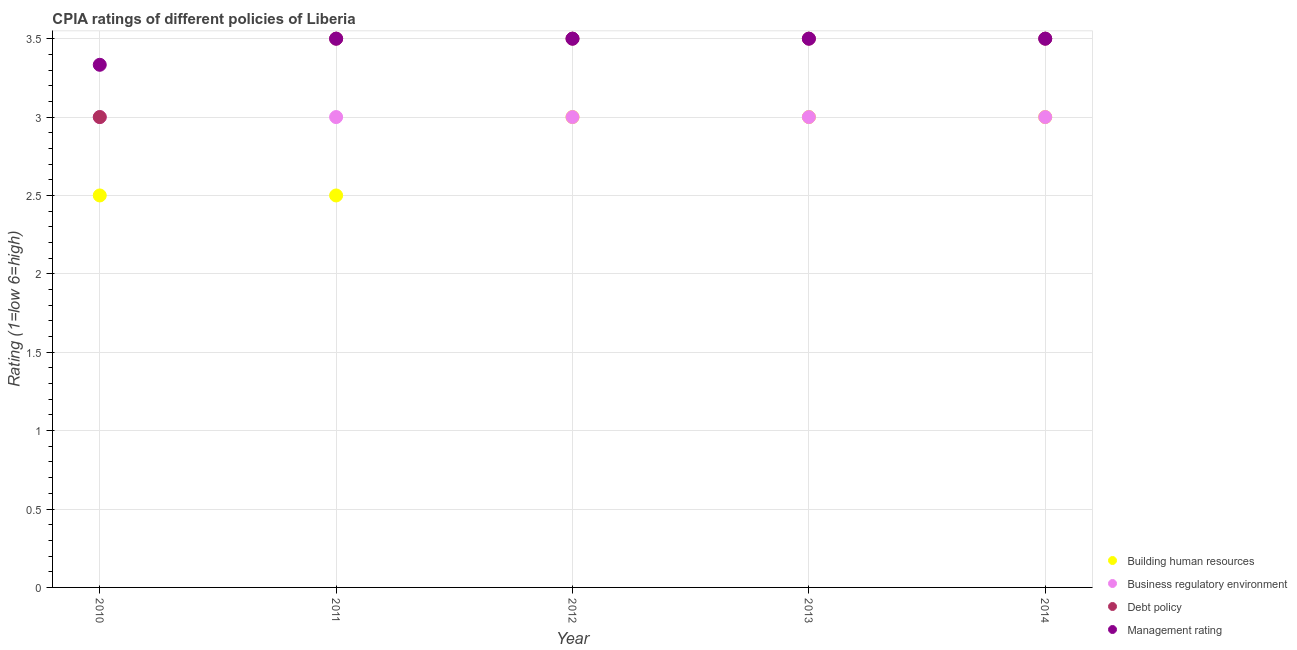Across all years, what is the minimum cpia rating of building human resources?
Offer a very short reply. 2.5. In which year was the cpia rating of management maximum?
Your answer should be compact. 2011. What is the total cpia rating of debt policy in the graph?
Offer a terse response. 17. What is the difference between the cpia rating of debt policy in 2010 and that in 2014?
Give a very brief answer. -0.5. What is the difference between the cpia rating of business regulatory environment in 2011 and the cpia rating of management in 2012?
Keep it short and to the point. -0.5. What is the average cpia rating of management per year?
Make the answer very short. 3.47. In the year 2014, what is the difference between the cpia rating of business regulatory environment and cpia rating of management?
Provide a succinct answer. -0.5. In how many years, is the cpia rating of management greater than 1?
Your response must be concise. 5. What is the ratio of the cpia rating of building human resources in 2012 to that in 2013?
Ensure brevity in your answer.  1. Is the cpia rating of debt policy in 2010 less than that in 2014?
Keep it short and to the point. Yes. Is the difference between the cpia rating of building human resources in 2011 and 2014 greater than the difference between the cpia rating of management in 2011 and 2014?
Make the answer very short. No. In how many years, is the cpia rating of building human resources greater than the average cpia rating of building human resources taken over all years?
Your response must be concise. 3. Is the sum of the cpia rating of business regulatory environment in 2010 and 2012 greater than the maximum cpia rating of management across all years?
Keep it short and to the point. Yes. Does the cpia rating of management monotonically increase over the years?
Provide a short and direct response. No. Is the cpia rating of building human resources strictly greater than the cpia rating of debt policy over the years?
Make the answer very short. No. How many years are there in the graph?
Make the answer very short. 5. Are the values on the major ticks of Y-axis written in scientific E-notation?
Your response must be concise. No. Does the graph contain any zero values?
Provide a succinct answer. No. Does the graph contain grids?
Provide a short and direct response. Yes. Where does the legend appear in the graph?
Your response must be concise. Bottom right. How many legend labels are there?
Provide a short and direct response. 4. What is the title of the graph?
Offer a very short reply. CPIA ratings of different policies of Liberia. Does "Energy" appear as one of the legend labels in the graph?
Offer a terse response. No. What is the label or title of the X-axis?
Offer a very short reply. Year. What is the label or title of the Y-axis?
Give a very brief answer. Rating (1=low 6=high). What is the Rating (1=low 6=high) in Building human resources in 2010?
Your answer should be very brief. 2.5. What is the Rating (1=low 6=high) in Business regulatory environment in 2010?
Make the answer very short. 3. What is the Rating (1=low 6=high) in Debt policy in 2010?
Your response must be concise. 3. What is the Rating (1=low 6=high) of Management rating in 2010?
Offer a terse response. 3.33. What is the Rating (1=low 6=high) of Business regulatory environment in 2012?
Your answer should be very brief. 3. What is the Rating (1=low 6=high) in Debt policy in 2013?
Offer a terse response. 3.5. What is the Rating (1=low 6=high) of Business regulatory environment in 2014?
Ensure brevity in your answer.  3. What is the Rating (1=low 6=high) in Management rating in 2014?
Give a very brief answer. 3.5. Across all years, what is the minimum Rating (1=low 6=high) in Building human resources?
Ensure brevity in your answer.  2.5. Across all years, what is the minimum Rating (1=low 6=high) in Business regulatory environment?
Your answer should be compact. 3. Across all years, what is the minimum Rating (1=low 6=high) of Debt policy?
Your answer should be very brief. 3. Across all years, what is the minimum Rating (1=low 6=high) of Management rating?
Keep it short and to the point. 3.33. What is the total Rating (1=low 6=high) in Management rating in the graph?
Your answer should be very brief. 17.33. What is the difference between the Rating (1=low 6=high) in Business regulatory environment in 2010 and that in 2011?
Your answer should be very brief. 0. What is the difference between the Rating (1=low 6=high) in Management rating in 2010 and that in 2011?
Your response must be concise. -0.17. What is the difference between the Rating (1=low 6=high) in Debt policy in 2010 and that in 2012?
Offer a terse response. -0.5. What is the difference between the Rating (1=low 6=high) in Management rating in 2010 and that in 2012?
Provide a succinct answer. -0.17. What is the difference between the Rating (1=low 6=high) of Building human resources in 2010 and that in 2013?
Offer a terse response. -0.5. What is the difference between the Rating (1=low 6=high) in Debt policy in 2010 and that in 2013?
Your response must be concise. -0.5. What is the difference between the Rating (1=low 6=high) of Debt policy in 2011 and that in 2012?
Your answer should be very brief. 0. What is the difference between the Rating (1=low 6=high) in Management rating in 2011 and that in 2012?
Your answer should be compact. 0. What is the difference between the Rating (1=low 6=high) of Building human resources in 2011 and that in 2013?
Provide a short and direct response. -0.5. What is the difference between the Rating (1=low 6=high) of Debt policy in 2011 and that in 2014?
Your response must be concise. 0. What is the difference between the Rating (1=low 6=high) in Management rating in 2011 and that in 2014?
Provide a short and direct response. 0. What is the difference between the Rating (1=low 6=high) in Building human resources in 2012 and that in 2013?
Your answer should be very brief. 0. What is the difference between the Rating (1=low 6=high) of Building human resources in 2012 and that in 2014?
Ensure brevity in your answer.  0. What is the difference between the Rating (1=low 6=high) of Debt policy in 2012 and that in 2014?
Provide a succinct answer. 0. What is the difference between the Rating (1=low 6=high) of Management rating in 2012 and that in 2014?
Give a very brief answer. 0. What is the difference between the Rating (1=low 6=high) of Building human resources in 2013 and that in 2014?
Your response must be concise. 0. What is the difference between the Rating (1=low 6=high) of Business regulatory environment in 2013 and that in 2014?
Offer a very short reply. 0. What is the difference between the Rating (1=low 6=high) of Building human resources in 2010 and the Rating (1=low 6=high) of Debt policy in 2011?
Offer a terse response. -1. What is the difference between the Rating (1=low 6=high) of Business regulatory environment in 2010 and the Rating (1=low 6=high) of Debt policy in 2011?
Your response must be concise. -0.5. What is the difference between the Rating (1=low 6=high) of Debt policy in 2010 and the Rating (1=low 6=high) of Management rating in 2011?
Ensure brevity in your answer.  -0.5. What is the difference between the Rating (1=low 6=high) in Building human resources in 2010 and the Rating (1=low 6=high) in Debt policy in 2012?
Provide a short and direct response. -1. What is the difference between the Rating (1=low 6=high) of Business regulatory environment in 2010 and the Rating (1=low 6=high) of Debt policy in 2012?
Make the answer very short. -0.5. What is the difference between the Rating (1=low 6=high) in Building human resources in 2010 and the Rating (1=low 6=high) in Business regulatory environment in 2013?
Ensure brevity in your answer.  -0.5. What is the difference between the Rating (1=low 6=high) in Building human resources in 2010 and the Rating (1=low 6=high) in Management rating in 2013?
Keep it short and to the point. -1. What is the difference between the Rating (1=low 6=high) in Business regulatory environment in 2010 and the Rating (1=low 6=high) in Debt policy in 2013?
Offer a very short reply. -0.5. What is the difference between the Rating (1=low 6=high) in Business regulatory environment in 2010 and the Rating (1=low 6=high) in Management rating in 2013?
Give a very brief answer. -0.5. What is the difference between the Rating (1=low 6=high) in Building human resources in 2010 and the Rating (1=low 6=high) in Debt policy in 2014?
Give a very brief answer. -1. What is the difference between the Rating (1=low 6=high) in Building human resources in 2010 and the Rating (1=low 6=high) in Management rating in 2014?
Your answer should be very brief. -1. What is the difference between the Rating (1=low 6=high) in Business regulatory environment in 2010 and the Rating (1=low 6=high) in Debt policy in 2014?
Your response must be concise. -0.5. What is the difference between the Rating (1=low 6=high) of Business regulatory environment in 2010 and the Rating (1=low 6=high) of Management rating in 2014?
Provide a succinct answer. -0.5. What is the difference between the Rating (1=low 6=high) in Debt policy in 2010 and the Rating (1=low 6=high) in Management rating in 2014?
Make the answer very short. -0.5. What is the difference between the Rating (1=low 6=high) in Building human resources in 2011 and the Rating (1=low 6=high) in Business regulatory environment in 2012?
Provide a succinct answer. -0.5. What is the difference between the Rating (1=low 6=high) of Business regulatory environment in 2011 and the Rating (1=low 6=high) of Debt policy in 2012?
Provide a succinct answer. -0.5. What is the difference between the Rating (1=low 6=high) of Business regulatory environment in 2011 and the Rating (1=low 6=high) of Management rating in 2012?
Make the answer very short. -0.5. What is the difference between the Rating (1=low 6=high) of Debt policy in 2011 and the Rating (1=low 6=high) of Management rating in 2012?
Ensure brevity in your answer.  0. What is the difference between the Rating (1=low 6=high) of Building human resources in 2011 and the Rating (1=low 6=high) of Management rating in 2013?
Offer a terse response. -1. What is the difference between the Rating (1=low 6=high) in Business regulatory environment in 2011 and the Rating (1=low 6=high) in Debt policy in 2013?
Your answer should be very brief. -0.5. What is the difference between the Rating (1=low 6=high) of Building human resources in 2011 and the Rating (1=low 6=high) of Business regulatory environment in 2014?
Offer a very short reply. -0.5. What is the difference between the Rating (1=low 6=high) in Building human resources in 2011 and the Rating (1=low 6=high) in Debt policy in 2014?
Give a very brief answer. -1. What is the difference between the Rating (1=low 6=high) of Building human resources in 2011 and the Rating (1=low 6=high) of Management rating in 2014?
Your answer should be very brief. -1. What is the difference between the Rating (1=low 6=high) of Business regulatory environment in 2011 and the Rating (1=low 6=high) of Management rating in 2014?
Make the answer very short. -0.5. What is the difference between the Rating (1=low 6=high) of Debt policy in 2011 and the Rating (1=low 6=high) of Management rating in 2014?
Your response must be concise. 0. What is the difference between the Rating (1=low 6=high) in Building human resources in 2012 and the Rating (1=low 6=high) in Business regulatory environment in 2013?
Provide a short and direct response. 0. What is the difference between the Rating (1=low 6=high) of Building human resources in 2012 and the Rating (1=low 6=high) of Debt policy in 2013?
Ensure brevity in your answer.  -0.5. What is the difference between the Rating (1=low 6=high) in Building human resources in 2012 and the Rating (1=low 6=high) in Management rating in 2013?
Provide a short and direct response. -0.5. What is the difference between the Rating (1=low 6=high) in Business regulatory environment in 2012 and the Rating (1=low 6=high) in Debt policy in 2013?
Offer a terse response. -0.5. What is the difference between the Rating (1=low 6=high) of Debt policy in 2012 and the Rating (1=low 6=high) of Management rating in 2013?
Provide a short and direct response. 0. What is the difference between the Rating (1=low 6=high) in Business regulatory environment in 2012 and the Rating (1=low 6=high) in Management rating in 2014?
Offer a terse response. -0.5. What is the difference between the Rating (1=low 6=high) of Building human resources in 2013 and the Rating (1=low 6=high) of Management rating in 2014?
Provide a short and direct response. -0.5. What is the difference between the Rating (1=low 6=high) of Business regulatory environment in 2013 and the Rating (1=low 6=high) of Debt policy in 2014?
Provide a succinct answer. -0.5. What is the difference between the Rating (1=low 6=high) of Debt policy in 2013 and the Rating (1=low 6=high) of Management rating in 2014?
Offer a very short reply. 0. What is the average Rating (1=low 6=high) in Business regulatory environment per year?
Provide a short and direct response. 3. What is the average Rating (1=low 6=high) in Management rating per year?
Provide a short and direct response. 3.47. In the year 2010, what is the difference between the Rating (1=low 6=high) of Building human resources and Rating (1=low 6=high) of Business regulatory environment?
Offer a very short reply. -0.5. In the year 2010, what is the difference between the Rating (1=low 6=high) of Building human resources and Rating (1=low 6=high) of Management rating?
Give a very brief answer. -0.83. In the year 2010, what is the difference between the Rating (1=low 6=high) of Business regulatory environment and Rating (1=low 6=high) of Management rating?
Keep it short and to the point. -0.33. In the year 2011, what is the difference between the Rating (1=low 6=high) in Building human resources and Rating (1=low 6=high) in Business regulatory environment?
Provide a succinct answer. -0.5. In the year 2011, what is the difference between the Rating (1=low 6=high) of Building human resources and Rating (1=low 6=high) of Debt policy?
Keep it short and to the point. -1. In the year 2011, what is the difference between the Rating (1=low 6=high) of Business regulatory environment and Rating (1=low 6=high) of Debt policy?
Provide a short and direct response. -0.5. In the year 2011, what is the difference between the Rating (1=low 6=high) in Business regulatory environment and Rating (1=low 6=high) in Management rating?
Your answer should be compact. -0.5. In the year 2011, what is the difference between the Rating (1=low 6=high) in Debt policy and Rating (1=low 6=high) in Management rating?
Give a very brief answer. 0. In the year 2012, what is the difference between the Rating (1=low 6=high) of Building human resources and Rating (1=low 6=high) of Business regulatory environment?
Your answer should be very brief. 0. In the year 2012, what is the difference between the Rating (1=low 6=high) in Building human resources and Rating (1=low 6=high) in Management rating?
Your answer should be very brief. -0.5. In the year 2012, what is the difference between the Rating (1=low 6=high) of Business regulatory environment and Rating (1=low 6=high) of Debt policy?
Offer a very short reply. -0.5. In the year 2012, what is the difference between the Rating (1=low 6=high) of Business regulatory environment and Rating (1=low 6=high) of Management rating?
Offer a very short reply. -0.5. In the year 2014, what is the difference between the Rating (1=low 6=high) of Business regulatory environment and Rating (1=low 6=high) of Debt policy?
Offer a terse response. -0.5. In the year 2014, what is the difference between the Rating (1=low 6=high) of Business regulatory environment and Rating (1=low 6=high) of Management rating?
Keep it short and to the point. -0.5. In the year 2014, what is the difference between the Rating (1=low 6=high) of Debt policy and Rating (1=low 6=high) of Management rating?
Give a very brief answer. 0. What is the ratio of the Rating (1=low 6=high) in Building human resources in 2010 to that in 2011?
Provide a succinct answer. 1. What is the ratio of the Rating (1=low 6=high) of Debt policy in 2010 to that in 2011?
Make the answer very short. 0.86. What is the ratio of the Rating (1=low 6=high) in Building human resources in 2010 to that in 2014?
Provide a succinct answer. 0.83. What is the ratio of the Rating (1=low 6=high) of Debt policy in 2010 to that in 2014?
Offer a terse response. 0.86. What is the ratio of the Rating (1=low 6=high) in Business regulatory environment in 2011 to that in 2012?
Offer a terse response. 1. What is the ratio of the Rating (1=low 6=high) of Debt policy in 2011 to that in 2012?
Keep it short and to the point. 1. What is the ratio of the Rating (1=low 6=high) of Building human resources in 2011 to that in 2013?
Give a very brief answer. 0.83. What is the ratio of the Rating (1=low 6=high) of Business regulatory environment in 2011 to that in 2013?
Provide a short and direct response. 1. What is the ratio of the Rating (1=low 6=high) in Management rating in 2011 to that in 2013?
Make the answer very short. 1. What is the ratio of the Rating (1=low 6=high) in Building human resources in 2011 to that in 2014?
Offer a terse response. 0.83. What is the ratio of the Rating (1=low 6=high) of Debt policy in 2011 to that in 2014?
Provide a succinct answer. 1. What is the ratio of the Rating (1=low 6=high) in Management rating in 2011 to that in 2014?
Offer a very short reply. 1. What is the ratio of the Rating (1=low 6=high) of Business regulatory environment in 2012 to that in 2013?
Offer a very short reply. 1. What is the ratio of the Rating (1=low 6=high) in Debt policy in 2012 to that in 2013?
Your answer should be very brief. 1. What is the ratio of the Rating (1=low 6=high) of Management rating in 2012 to that in 2013?
Your answer should be compact. 1. What is the ratio of the Rating (1=low 6=high) of Debt policy in 2012 to that in 2014?
Ensure brevity in your answer.  1. What is the ratio of the Rating (1=low 6=high) of Management rating in 2012 to that in 2014?
Ensure brevity in your answer.  1. What is the ratio of the Rating (1=low 6=high) in Building human resources in 2013 to that in 2014?
Your answer should be very brief. 1. What is the ratio of the Rating (1=low 6=high) of Business regulatory environment in 2013 to that in 2014?
Ensure brevity in your answer.  1. What is the ratio of the Rating (1=low 6=high) of Management rating in 2013 to that in 2014?
Keep it short and to the point. 1. What is the difference between the highest and the second highest Rating (1=low 6=high) of Building human resources?
Make the answer very short. 0. What is the difference between the highest and the second highest Rating (1=low 6=high) of Management rating?
Make the answer very short. 0. What is the difference between the highest and the lowest Rating (1=low 6=high) of Building human resources?
Your answer should be compact. 0.5. What is the difference between the highest and the lowest Rating (1=low 6=high) in Business regulatory environment?
Provide a short and direct response. 0. What is the difference between the highest and the lowest Rating (1=low 6=high) of Management rating?
Your answer should be very brief. 0.17. 